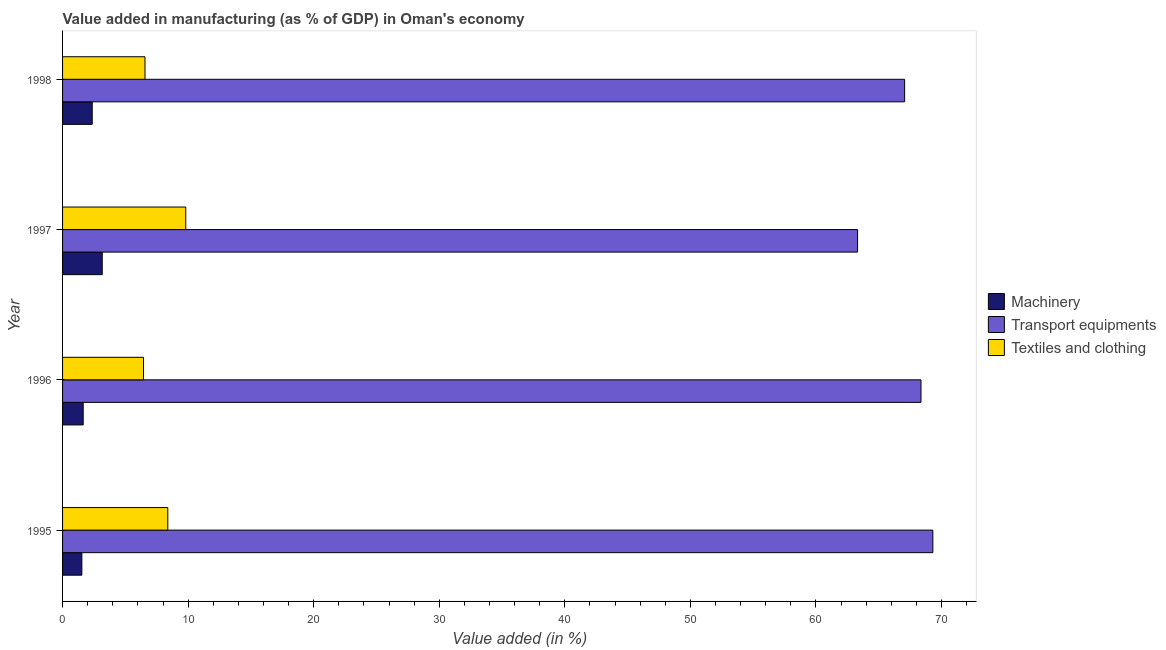How many groups of bars are there?
Ensure brevity in your answer.  4. How many bars are there on the 3rd tick from the top?
Keep it short and to the point. 3. What is the value added in manufacturing machinery in 1997?
Give a very brief answer. 3.16. Across all years, what is the maximum value added in manufacturing machinery?
Provide a short and direct response. 3.16. Across all years, what is the minimum value added in manufacturing transport equipments?
Keep it short and to the point. 63.31. In which year was the value added in manufacturing transport equipments maximum?
Provide a short and direct response. 1995. In which year was the value added in manufacturing textile and clothing minimum?
Give a very brief answer. 1996. What is the total value added in manufacturing textile and clothing in the graph?
Offer a very short reply. 31.2. What is the difference between the value added in manufacturing machinery in 1995 and that in 1997?
Provide a short and direct response. -1.62. What is the difference between the value added in manufacturing textile and clothing in 1997 and the value added in manufacturing transport equipments in 1998?
Your answer should be very brief. -57.25. What is the average value added in manufacturing textile and clothing per year?
Make the answer very short. 7.8. In the year 1998, what is the difference between the value added in manufacturing textile and clothing and value added in manufacturing transport equipments?
Your response must be concise. -60.5. In how many years, is the value added in manufacturing machinery greater than 30 %?
Make the answer very short. 0. What is the ratio of the value added in manufacturing textile and clothing in 1995 to that in 1996?
Offer a very short reply. 1.3. Is the value added in manufacturing textile and clothing in 1996 less than that in 1997?
Provide a succinct answer. Yes. What is the difference between the highest and the second highest value added in manufacturing machinery?
Ensure brevity in your answer.  0.8. What does the 1st bar from the top in 1997 represents?
Provide a succinct answer. Textiles and clothing. What does the 3rd bar from the bottom in 1997 represents?
Ensure brevity in your answer.  Textiles and clothing. Is it the case that in every year, the sum of the value added in manufacturing machinery and value added in manufacturing transport equipments is greater than the value added in manufacturing textile and clothing?
Your response must be concise. Yes. How many bars are there?
Ensure brevity in your answer.  12. Are all the bars in the graph horizontal?
Your response must be concise. Yes. How many years are there in the graph?
Your answer should be compact. 4. What is the difference between two consecutive major ticks on the X-axis?
Ensure brevity in your answer.  10. Are the values on the major ticks of X-axis written in scientific E-notation?
Keep it short and to the point. No. Does the graph contain any zero values?
Your answer should be compact. No. Does the graph contain grids?
Ensure brevity in your answer.  No. How many legend labels are there?
Keep it short and to the point. 3. What is the title of the graph?
Ensure brevity in your answer.  Value added in manufacturing (as % of GDP) in Oman's economy. What is the label or title of the X-axis?
Ensure brevity in your answer.  Value added (in %). What is the label or title of the Y-axis?
Keep it short and to the point. Year. What is the Value added (in %) of Machinery in 1995?
Offer a very short reply. 1.54. What is the Value added (in %) of Transport equipments in 1995?
Offer a terse response. 69.31. What is the Value added (in %) in Textiles and clothing in 1995?
Ensure brevity in your answer.  8.38. What is the Value added (in %) in Machinery in 1996?
Provide a succinct answer. 1.64. What is the Value added (in %) in Transport equipments in 1996?
Offer a very short reply. 68.36. What is the Value added (in %) of Textiles and clothing in 1996?
Offer a terse response. 6.45. What is the Value added (in %) in Machinery in 1997?
Offer a terse response. 3.16. What is the Value added (in %) of Transport equipments in 1997?
Make the answer very short. 63.31. What is the Value added (in %) of Textiles and clothing in 1997?
Provide a short and direct response. 9.81. What is the Value added (in %) of Machinery in 1998?
Offer a very short reply. 2.36. What is the Value added (in %) in Transport equipments in 1998?
Keep it short and to the point. 67.06. What is the Value added (in %) of Textiles and clothing in 1998?
Make the answer very short. 6.56. Across all years, what is the maximum Value added (in %) in Machinery?
Your answer should be compact. 3.16. Across all years, what is the maximum Value added (in %) in Transport equipments?
Provide a succinct answer. 69.31. Across all years, what is the maximum Value added (in %) of Textiles and clothing?
Keep it short and to the point. 9.81. Across all years, what is the minimum Value added (in %) in Machinery?
Your answer should be very brief. 1.54. Across all years, what is the minimum Value added (in %) of Transport equipments?
Your answer should be compact. 63.31. Across all years, what is the minimum Value added (in %) of Textiles and clothing?
Your response must be concise. 6.45. What is the total Value added (in %) of Machinery in the graph?
Provide a short and direct response. 8.7. What is the total Value added (in %) of Transport equipments in the graph?
Give a very brief answer. 268.05. What is the total Value added (in %) of Textiles and clothing in the graph?
Provide a short and direct response. 31.2. What is the difference between the Value added (in %) of Machinery in 1995 and that in 1996?
Give a very brief answer. -0.11. What is the difference between the Value added (in %) in Transport equipments in 1995 and that in 1996?
Provide a short and direct response. 0.95. What is the difference between the Value added (in %) in Textiles and clothing in 1995 and that in 1996?
Provide a succinct answer. 1.93. What is the difference between the Value added (in %) in Machinery in 1995 and that in 1997?
Your answer should be compact. -1.62. What is the difference between the Value added (in %) of Transport equipments in 1995 and that in 1997?
Give a very brief answer. 6. What is the difference between the Value added (in %) in Textiles and clothing in 1995 and that in 1997?
Offer a terse response. -1.43. What is the difference between the Value added (in %) of Machinery in 1995 and that in 1998?
Offer a terse response. -0.82. What is the difference between the Value added (in %) of Transport equipments in 1995 and that in 1998?
Ensure brevity in your answer.  2.25. What is the difference between the Value added (in %) of Textiles and clothing in 1995 and that in 1998?
Keep it short and to the point. 1.82. What is the difference between the Value added (in %) of Machinery in 1996 and that in 1997?
Provide a succinct answer. -1.52. What is the difference between the Value added (in %) in Transport equipments in 1996 and that in 1997?
Provide a short and direct response. 5.05. What is the difference between the Value added (in %) of Textiles and clothing in 1996 and that in 1997?
Your answer should be compact. -3.37. What is the difference between the Value added (in %) in Machinery in 1996 and that in 1998?
Provide a succinct answer. -0.72. What is the difference between the Value added (in %) in Transport equipments in 1996 and that in 1998?
Give a very brief answer. 1.3. What is the difference between the Value added (in %) in Textiles and clothing in 1996 and that in 1998?
Ensure brevity in your answer.  -0.12. What is the difference between the Value added (in %) of Machinery in 1997 and that in 1998?
Ensure brevity in your answer.  0.8. What is the difference between the Value added (in %) in Transport equipments in 1997 and that in 1998?
Give a very brief answer. -3.75. What is the difference between the Value added (in %) of Textiles and clothing in 1997 and that in 1998?
Your answer should be very brief. 3.25. What is the difference between the Value added (in %) in Machinery in 1995 and the Value added (in %) in Transport equipments in 1996?
Offer a terse response. -66.83. What is the difference between the Value added (in %) of Machinery in 1995 and the Value added (in %) of Textiles and clothing in 1996?
Offer a very short reply. -4.91. What is the difference between the Value added (in %) of Transport equipments in 1995 and the Value added (in %) of Textiles and clothing in 1996?
Keep it short and to the point. 62.86. What is the difference between the Value added (in %) of Machinery in 1995 and the Value added (in %) of Transport equipments in 1997?
Provide a short and direct response. -61.78. What is the difference between the Value added (in %) of Machinery in 1995 and the Value added (in %) of Textiles and clothing in 1997?
Your answer should be very brief. -8.28. What is the difference between the Value added (in %) of Transport equipments in 1995 and the Value added (in %) of Textiles and clothing in 1997?
Provide a short and direct response. 59.5. What is the difference between the Value added (in %) in Machinery in 1995 and the Value added (in %) in Transport equipments in 1998?
Offer a terse response. -65.52. What is the difference between the Value added (in %) in Machinery in 1995 and the Value added (in %) in Textiles and clothing in 1998?
Make the answer very short. -5.03. What is the difference between the Value added (in %) of Transport equipments in 1995 and the Value added (in %) of Textiles and clothing in 1998?
Offer a very short reply. 62.75. What is the difference between the Value added (in %) of Machinery in 1996 and the Value added (in %) of Transport equipments in 1997?
Give a very brief answer. -61.67. What is the difference between the Value added (in %) of Machinery in 1996 and the Value added (in %) of Textiles and clothing in 1997?
Provide a succinct answer. -8.17. What is the difference between the Value added (in %) in Transport equipments in 1996 and the Value added (in %) in Textiles and clothing in 1997?
Offer a very short reply. 58.55. What is the difference between the Value added (in %) of Machinery in 1996 and the Value added (in %) of Transport equipments in 1998?
Give a very brief answer. -65.42. What is the difference between the Value added (in %) in Machinery in 1996 and the Value added (in %) in Textiles and clothing in 1998?
Offer a terse response. -4.92. What is the difference between the Value added (in %) of Transport equipments in 1996 and the Value added (in %) of Textiles and clothing in 1998?
Make the answer very short. 61.8. What is the difference between the Value added (in %) in Machinery in 1997 and the Value added (in %) in Transport equipments in 1998?
Your response must be concise. -63.9. What is the difference between the Value added (in %) in Machinery in 1997 and the Value added (in %) in Textiles and clothing in 1998?
Provide a short and direct response. -3.4. What is the difference between the Value added (in %) of Transport equipments in 1997 and the Value added (in %) of Textiles and clothing in 1998?
Offer a terse response. 56.75. What is the average Value added (in %) in Machinery per year?
Your answer should be very brief. 2.17. What is the average Value added (in %) in Transport equipments per year?
Ensure brevity in your answer.  67.01. What is the average Value added (in %) of Textiles and clothing per year?
Provide a short and direct response. 7.8. In the year 1995, what is the difference between the Value added (in %) of Machinery and Value added (in %) of Transport equipments?
Your answer should be very brief. -67.77. In the year 1995, what is the difference between the Value added (in %) in Machinery and Value added (in %) in Textiles and clothing?
Offer a terse response. -6.84. In the year 1995, what is the difference between the Value added (in %) of Transport equipments and Value added (in %) of Textiles and clothing?
Offer a very short reply. 60.93. In the year 1996, what is the difference between the Value added (in %) in Machinery and Value added (in %) in Transport equipments?
Your response must be concise. -66.72. In the year 1996, what is the difference between the Value added (in %) of Machinery and Value added (in %) of Textiles and clothing?
Keep it short and to the point. -4.8. In the year 1996, what is the difference between the Value added (in %) in Transport equipments and Value added (in %) in Textiles and clothing?
Provide a succinct answer. 61.92. In the year 1997, what is the difference between the Value added (in %) in Machinery and Value added (in %) in Transport equipments?
Provide a short and direct response. -60.15. In the year 1997, what is the difference between the Value added (in %) of Machinery and Value added (in %) of Textiles and clothing?
Offer a terse response. -6.65. In the year 1997, what is the difference between the Value added (in %) of Transport equipments and Value added (in %) of Textiles and clothing?
Offer a terse response. 53.5. In the year 1998, what is the difference between the Value added (in %) of Machinery and Value added (in %) of Transport equipments?
Provide a short and direct response. -64.7. In the year 1998, what is the difference between the Value added (in %) in Machinery and Value added (in %) in Textiles and clothing?
Offer a terse response. -4.2. In the year 1998, what is the difference between the Value added (in %) in Transport equipments and Value added (in %) in Textiles and clothing?
Provide a short and direct response. 60.5. What is the ratio of the Value added (in %) of Machinery in 1995 to that in 1996?
Offer a terse response. 0.94. What is the ratio of the Value added (in %) in Transport equipments in 1995 to that in 1996?
Offer a terse response. 1.01. What is the ratio of the Value added (in %) of Textiles and clothing in 1995 to that in 1996?
Your answer should be very brief. 1.3. What is the ratio of the Value added (in %) of Machinery in 1995 to that in 1997?
Offer a very short reply. 0.49. What is the ratio of the Value added (in %) in Transport equipments in 1995 to that in 1997?
Provide a succinct answer. 1.09. What is the ratio of the Value added (in %) of Textiles and clothing in 1995 to that in 1997?
Ensure brevity in your answer.  0.85. What is the ratio of the Value added (in %) of Machinery in 1995 to that in 1998?
Your answer should be very brief. 0.65. What is the ratio of the Value added (in %) of Transport equipments in 1995 to that in 1998?
Ensure brevity in your answer.  1.03. What is the ratio of the Value added (in %) of Textiles and clothing in 1995 to that in 1998?
Offer a very short reply. 1.28. What is the ratio of the Value added (in %) of Machinery in 1996 to that in 1997?
Keep it short and to the point. 0.52. What is the ratio of the Value added (in %) of Transport equipments in 1996 to that in 1997?
Your answer should be very brief. 1.08. What is the ratio of the Value added (in %) of Textiles and clothing in 1996 to that in 1997?
Keep it short and to the point. 0.66. What is the ratio of the Value added (in %) of Machinery in 1996 to that in 1998?
Make the answer very short. 0.7. What is the ratio of the Value added (in %) of Transport equipments in 1996 to that in 1998?
Keep it short and to the point. 1.02. What is the ratio of the Value added (in %) of Textiles and clothing in 1996 to that in 1998?
Your answer should be very brief. 0.98. What is the ratio of the Value added (in %) in Machinery in 1997 to that in 1998?
Offer a terse response. 1.34. What is the ratio of the Value added (in %) of Transport equipments in 1997 to that in 1998?
Your response must be concise. 0.94. What is the ratio of the Value added (in %) of Textiles and clothing in 1997 to that in 1998?
Give a very brief answer. 1.49. What is the difference between the highest and the second highest Value added (in %) of Machinery?
Offer a terse response. 0.8. What is the difference between the highest and the second highest Value added (in %) in Transport equipments?
Make the answer very short. 0.95. What is the difference between the highest and the second highest Value added (in %) in Textiles and clothing?
Your response must be concise. 1.43. What is the difference between the highest and the lowest Value added (in %) in Machinery?
Your response must be concise. 1.62. What is the difference between the highest and the lowest Value added (in %) of Transport equipments?
Provide a succinct answer. 6. What is the difference between the highest and the lowest Value added (in %) in Textiles and clothing?
Give a very brief answer. 3.37. 